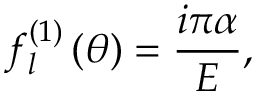<formula> <loc_0><loc_0><loc_500><loc_500>f _ { l } ^ { \left ( 1 \right ) } \left ( \theta \right ) = \frac { i \pi \alpha } { E } ,</formula> 